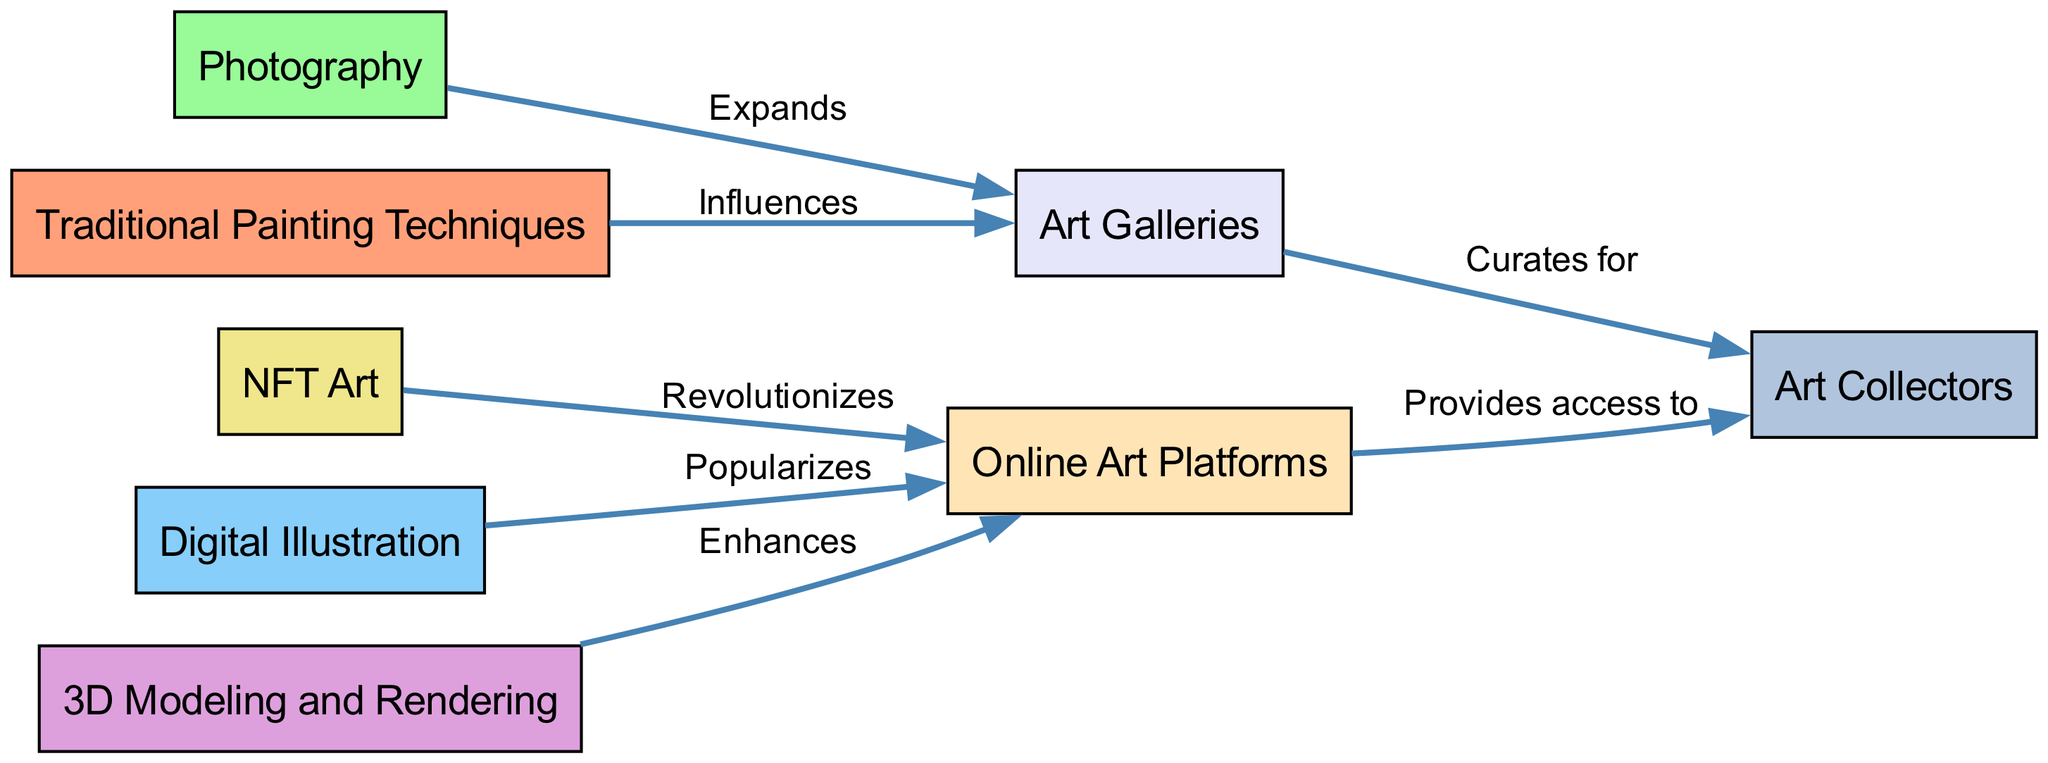What is the first node in the art evolution food chain? The first node listed in the diagram is "Traditional Painting Techniques". It is the starting point of the flow in the food chain diagram.
Answer: Traditional Painting Techniques How many nodes are there in the diagram? The total number of nodes represents different artistic techniques and platforms. By counting them, we find there are 8 distinct nodes.
Answer: 8 What type of relationship exists between Photography and Art Galleries? The edge from Photography to Art Galleries is labeled "Expands," indicating that Photography expands the presence and relevance of Art Galleries within the artistic community.
Answer: Expands Which node does Digital Illustration provide access to? Digital Illustration connects to Online Art Platforms through the "Popularizes" relationship, suggesting it enhances the accessibility of art.
Answer: Online Art Platforms What is the final step in the flow from Art Galleries to Art Collectors? The Ar Gallery has a direct edge going to Art Collectors labeled "Curates for," indicating that it plays a role in curating and shaping the collections of Art Collectors.
Answer: Curates for How many edges are represented in the diagram? By counting the lines connecting the nodes, it results in a total of 7 edges, each representing the relationships between the techniques and platforms.
Answer: 7 What effect does NFT Art have on Online Art Platforms? NFT Art has a relationship with Online Art Platforms labeled "Revolutionizes," indicating that it introduces significant changes to how art can be created, marketed, and sold online.
Answer: Revolutionizes How does 3D Modeling and Rendering influence Online Art Platforms? It connects to Online Art Platforms through the edge labeled "Enhances," showing that it adds value and capabilities for showcasing digital art online.
Answer: Enhances 